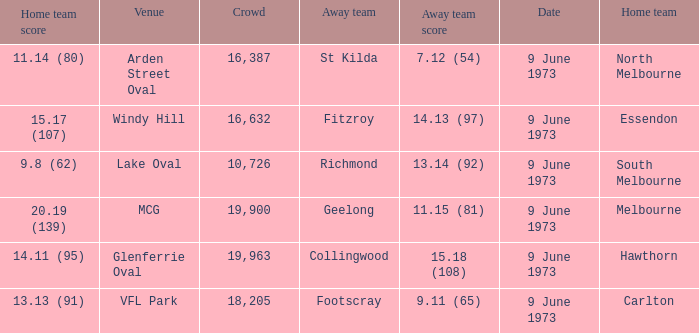What was North Melbourne's score as the home team? 11.14 (80). 